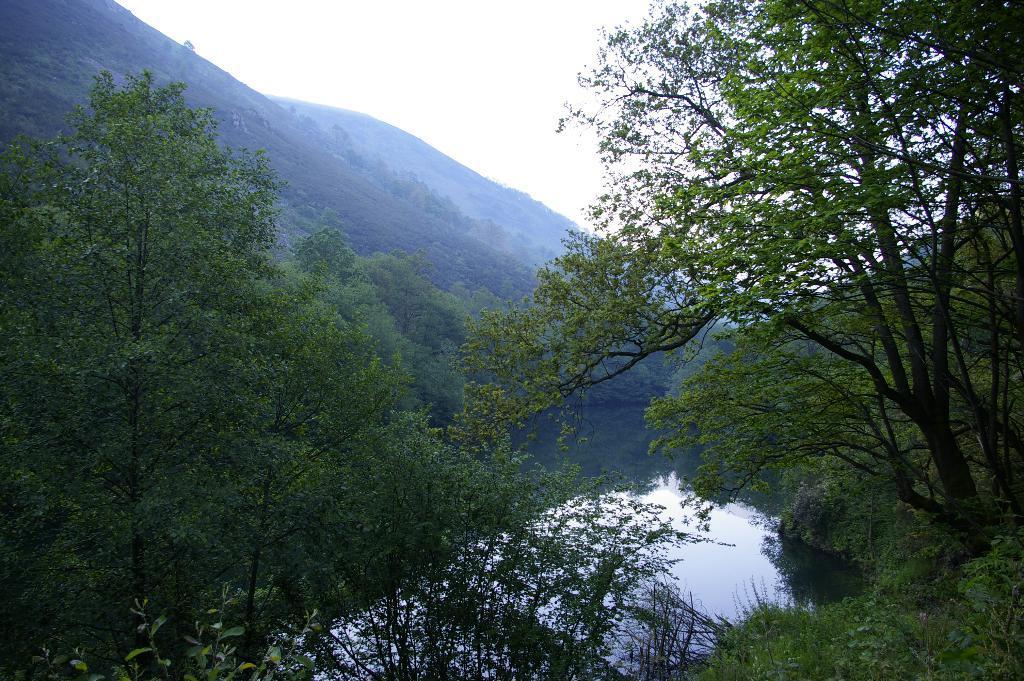Describe this image in one or two sentences. In this image there are trees on the left and right corner. There is water at the bottom. There are trees and mountains in the background. And there is sky at the top. 